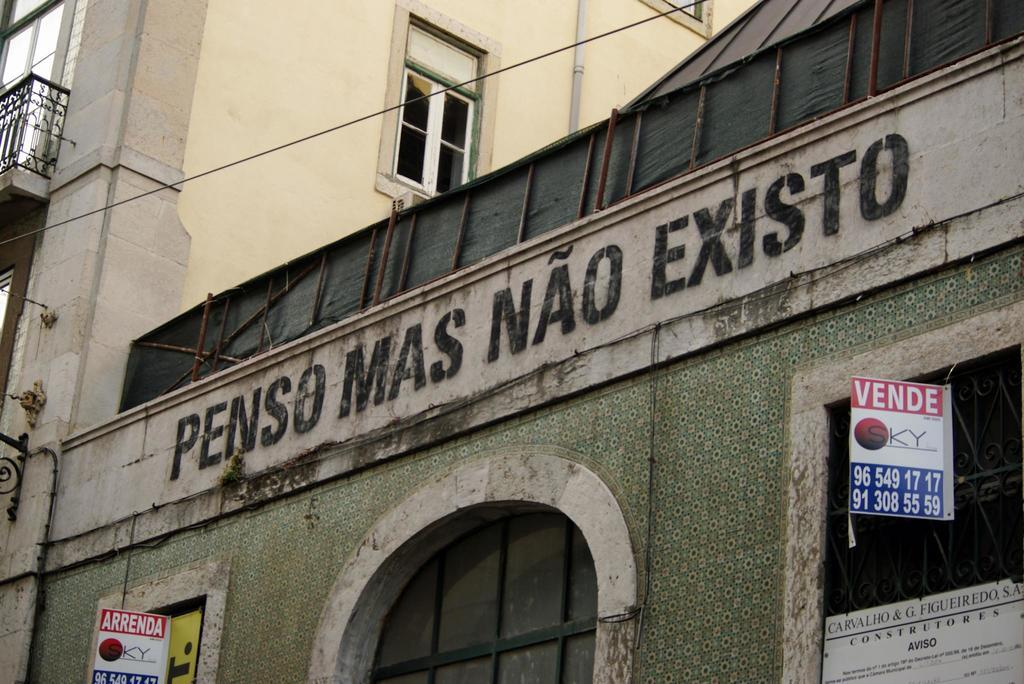What type of structure is visible in the image? There is a building in the image. What can be seen on the building? There is text on the building and boards with text at the bottom of the building. What type of windows does the building have? The building has glass windows. What safety feature is present on the building? The building has a railing. What type of yam is being used to hold the boards at the bottom of the building? There is no yam present in the image; the boards are supported by the building itself. How many fingers are visible holding the text on the building? There are no fingers visible in the image; the text is printed or displayed on the building. 